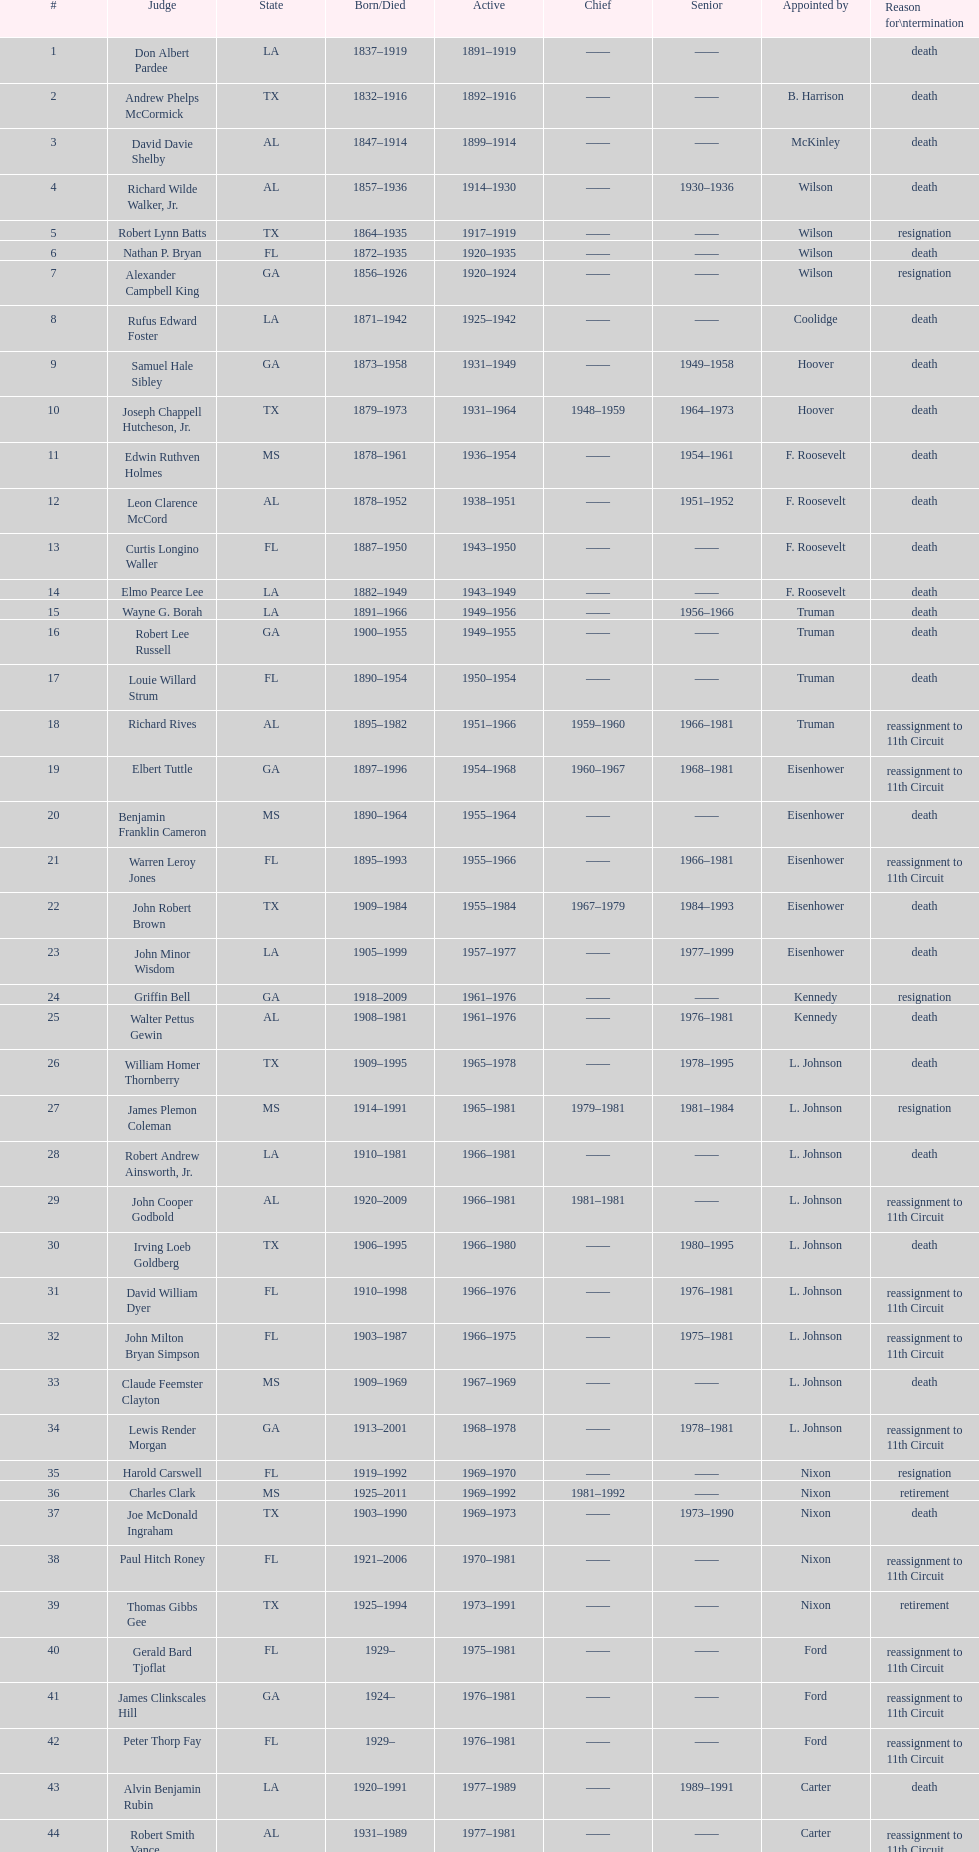Who was the only judge appointed by mckinley? David Davie Shelby. Would you mind parsing the complete table? {'header': ['#', 'Judge', 'State', 'Born/Died', 'Active', 'Chief', 'Senior', 'Appointed by', 'Reason for\\ntermination'], 'rows': [['1', 'Don Albert Pardee', 'LA', '1837–1919', '1891–1919', '——', '——', '', 'death'], ['2', 'Andrew Phelps McCormick', 'TX', '1832–1916', '1892–1916', '——', '——', 'B. Harrison', 'death'], ['3', 'David Davie Shelby', 'AL', '1847–1914', '1899–1914', '——', '——', 'McKinley', 'death'], ['4', 'Richard Wilde Walker, Jr.', 'AL', '1857–1936', '1914–1930', '——', '1930–1936', 'Wilson', 'death'], ['5', 'Robert Lynn Batts', 'TX', '1864–1935', '1917–1919', '——', '——', 'Wilson', 'resignation'], ['6', 'Nathan P. Bryan', 'FL', '1872–1935', '1920–1935', '——', '——', 'Wilson', 'death'], ['7', 'Alexander Campbell King', 'GA', '1856–1926', '1920–1924', '——', '——', 'Wilson', 'resignation'], ['8', 'Rufus Edward Foster', 'LA', '1871–1942', '1925–1942', '——', '——', 'Coolidge', 'death'], ['9', 'Samuel Hale Sibley', 'GA', '1873–1958', '1931–1949', '——', '1949–1958', 'Hoover', 'death'], ['10', 'Joseph Chappell Hutcheson, Jr.', 'TX', '1879–1973', '1931–1964', '1948–1959', '1964–1973', 'Hoover', 'death'], ['11', 'Edwin Ruthven Holmes', 'MS', '1878–1961', '1936–1954', '——', '1954–1961', 'F. Roosevelt', 'death'], ['12', 'Leon Clarence McCord', 'AL', '1878–1952', '1938–1951', '——', '1951–1952', 'F. Roosevelt', 'death'], ['13', 'Curtis Longino Waller', 'FL', '1887–1950', '1943–1950', '——', '——', 'F. Roosevelt', 'death'], ['14', 'Elmo Pearce Lee', 'LA', '1882–1949', '1943–1949', '——', '——', 'F. Roosevelt', 'death'], ['15', 'Wayne G. Borah', 'LA', '1891–1966', '1949–1956', '——', '1956–1966', 'Truman', 'death'], ['16', 'Robert Lee Russell', 'GA', '1900–1955', '1949–1955', '——', '——', 'Truman', 'death'], ['17', 'Louie Willard Strum', 'FL', '1890–1954', '1950–1954', '——', '——', 'Truman', 'death'], ['18', 'Richard Rives', 'AL', '1895–1982', '1951–1966', '1959–1960', '1966–1981', 'Truman', 'reassignment to 11th Circuit'], ['19', 'Elbert Tuttle', 'GA', '1897–1996', '1954–1968', '1960–1967', '1968–1981', 'Eisenhower', 'reassignment to 11th Circuit'], ['20', 'Benjamin Franklin Cameron', 'MS', '1890–1964', '1955–1964', '——', '——', 'Eisenhower', 'death'], ['21', 'Warren Leroy Jones', 'FL', '1895–1993', '1955–1966', '——', '1966–1981', 'Eisenhower', 'reassignment to 11th Circuit'], ['22', 'John Robert Brown', 'TX', '1909–1984', '1955–1984', '1967–1979', '1984–1993', 'Eisenhower', 'death'], ['23', 'John Minor Wisdom', 'LA', '1905–1999', '1957–1977', '——', '1977–1999', 'Eisenhower', 'death'], ['24', 'Griffin Bell', 'GA', '1918–2009', '1961–1976', '——', '——', 'Kennedy', 'resignation'], ['25', 'Walter Pettus Gewin', 'AL', '1908–1981', '1961–1976', '——', '1976–1981', 'Kennedy', 'death'], ['26', 'William Homer Thornberry', 'TX', '1909–1995', '1965–1978', '——', '1978–1995', 'L. Johnson', 'death'], ['27', 'James Plemon Coleman', 'MS', '1914–1991', '1965–1981', '1979–1981', '1981–1984', 'L. Johnson', 'resignation'], ['28', 'Robert Andrew Ainsworth, Jr.', 'LA', '1910–1981', '1966–1981', '——', '——', 'L. Johnson', 'death'], ['29', 'John Cooper Godbold', 'AL', '1920–2009', '1966–1981', '1981–1981', '——', 'L. Johnson', 'reassignment to 11th Circuit'], ['30', 'Irving Loeb Goldberg', 'TX', '1906–1995', '1966–1980', '——', '1980–1995', 'L. Johnson', 'death'], ['31', 'David William Dyer', 'FL', '1910–1998', '1966–1976', '——', '1976–1981', 'L. Johnson', 'reassignment to 11th Circuit'], ['32', 'John Milton Bryan Simpson', 'FL', '1903–1987', '1966–1975', '——', '1975–1981', 'L. Johnson', 'reassignment to 11th Circuit'], ['33', 'Claude Feemster Clayton', 'MS', '1909–1969', '1967–1969', '——', '——', 'L. Johnson', 'death'], ['34', 'Lewis Render Morgan', 'GA', '1913–2001', '1968–1978', '——', '1978–1981', 'L. Johnson', 'reassignment to 11th Circuit'], ['35', 'Harold Carswell', 'FL', '1919–1992', '1969–1970', '——', '——', 'Nixon', 'resignation'], ['36', 'Charles Clark', 'MS', '1925–2011', '1969–1992', '1981–1992', '——', 'Nixon', 'retirement'], ['37', 'Joe McDonald Ingraham', 'TX', '1903–1990', '1969–1973', '——', '1973–1990', 'Nixon', 'death'], ['38', 'Paul Hitch Roney', 'FL', '1921–2006', '1970–1981', '——', '——', 'Nixon', 'reassignment to 11th Circuit'], ['39', 'Thomas Gibbs Gee', 'TX', '1925–1994', '1973–1991', '——', '——', 'Nixon', 'retirement'], ['40', 'Gerald Bard Tjoflat', 'FL', '1929–', '1975–1981', '——', '——', 'Ford', 'reassignment to 11th Circuit'], ['41', 'James Clinkscales Hill', 'GA', '1924–', '1976–1981', '——', '——', 'Ford', 'reassignment to 11th Circuit'], ['42', 'Peter Thorp Fay', 'FL', '1929–', '1976–1981', '——', '——', 'Ford', 'reassignment to 11th Circuit'], ['43', 'Alvin Benjamin Rubin', 'LA', '1920–1991', '1977–1989', '——', '1989–1991', 'Carter', 'death'], ['44', 'Robert Smith Vance', 'AL', '1931–1989', '1977–1981', '——', '——', 'Carter', 'reassignment to 11th Circuit'], ['45', 'Phyllis A. Kravitch', 'GA', '1920–', '1979–1981', '——', '——', 'Carter', 'reassignment to 11th Circuit'], ['46', 'Frank Minis Johnson', 'AL', '1918–1999', '1979–1981', '——', '——', 'Carter', 'reassignment to 11th Circuit'], ['47', 'R. Lanier Anderson III', 'GA', '1936–', '1979–1981', '——', '——', 'Carter', 'reassignment to 11th Circuit'], ['48', 'Reynaldo Guerra Garza', 'TX', '1915–2004', '1979–1982', '——', '1982–2004', 'Carter', 'death'], ['49', 'Joseph Woodrow Hatchett', 'FL', '1932–', '1979–1981', '——', '——', 'Carter', 'reassignment to 11th Circuit'], ['50', 'Albert John Henderson', 'GA', '1920–1999', '1979–1981', '——', '——', 'Carter', 'reassignment to 11th Circuit'], ['52', 'Henry Anthony Politz', 'LA', '1932–2002', '1979–1999', '1992–1999', '1999–2002', 'Carter', 'death'], ['54', 'Samuel D. Johnson, Jr.', 'TX', '1920–2002', '1979–1991', '——', '1991–2002', 'Carter', 'death'], ['55', 'Albert Tate, Jr.', 'LA', '1920–1986', '1979–1986', '——', '——', 'Carter', 'death'], ['56', 'Thomas Alonzo Clark', 'GA', '1920–2005', '1979–1981', '——', '——', 'Carter', 'reassignment to 11th Circuit'], ['57', 'Jerre Stockton Williams', 'TX', '1916–1993', '1980–1990', '——', '1990–1993', 'Carter', 'death'], ['58', 'William Lockhart Garwood', 'TX', '1931–2011', '1981–1997', '——', '1997–2011', 'Reagan', 'death'], ['62', 'Robert Madden Hill', 'TX', '1928–1987', '1984–1987', '——', '——', 'Reagan', 'death'], ['65', 'John Malcolm Duhé, Jr.', 'LA', '1933-', '1988–1999', '——', '1999–2011', 'Reagan', 'retirement'], ['72', 'Robert Manley Parker', 'TX', '1937–', '1994–2002', '——', '——', 'Clinton', 'retirement'], ['76', 'Charles W. Pickering', 'MS', '1937–', '2004–2004', '——', '——', 'G.W. Bush', 'retirement']]} 